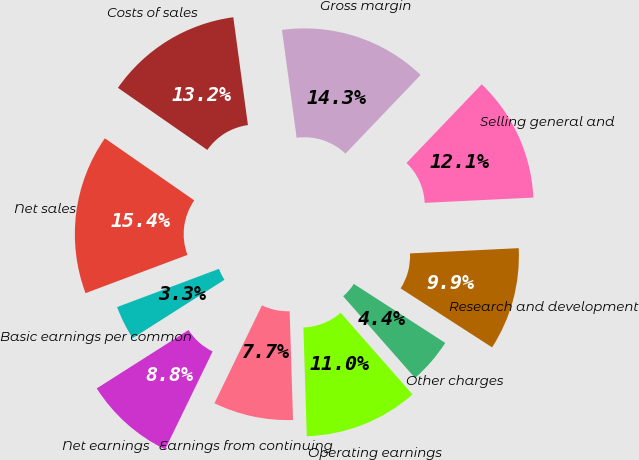<chart> <loc_0><loc_0><loc_500><loc_500><pie_chart><fcel>Net sales<fcel>Costs of sales<fcel>Gross margin<fcel>Selling general and<fcel>Research and development<fcel>Other charges<fcel>Operating earnings<fcel>Earnings from continuing<fcel>Net earnings<fcel>Basic earnings per common<nl><fcel>15.38%<fcel>13.19%<fcel>14.29%<fcel>12.09%<fcel>9.89%<fcel>4.4%<fcel>10.99%<fcel>7.69%<fcel>8.79%<fcel>3.3%<nl></chart> 